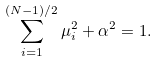<formula> <loc_0><loc_0><loc_500><loc_500>\sum _ { i = 1 } ^ { ( N - 1 ) / 2 } \mu _ { i } ^ { 2 } + \alpha ^ { 2 } = 1 .</formula> 